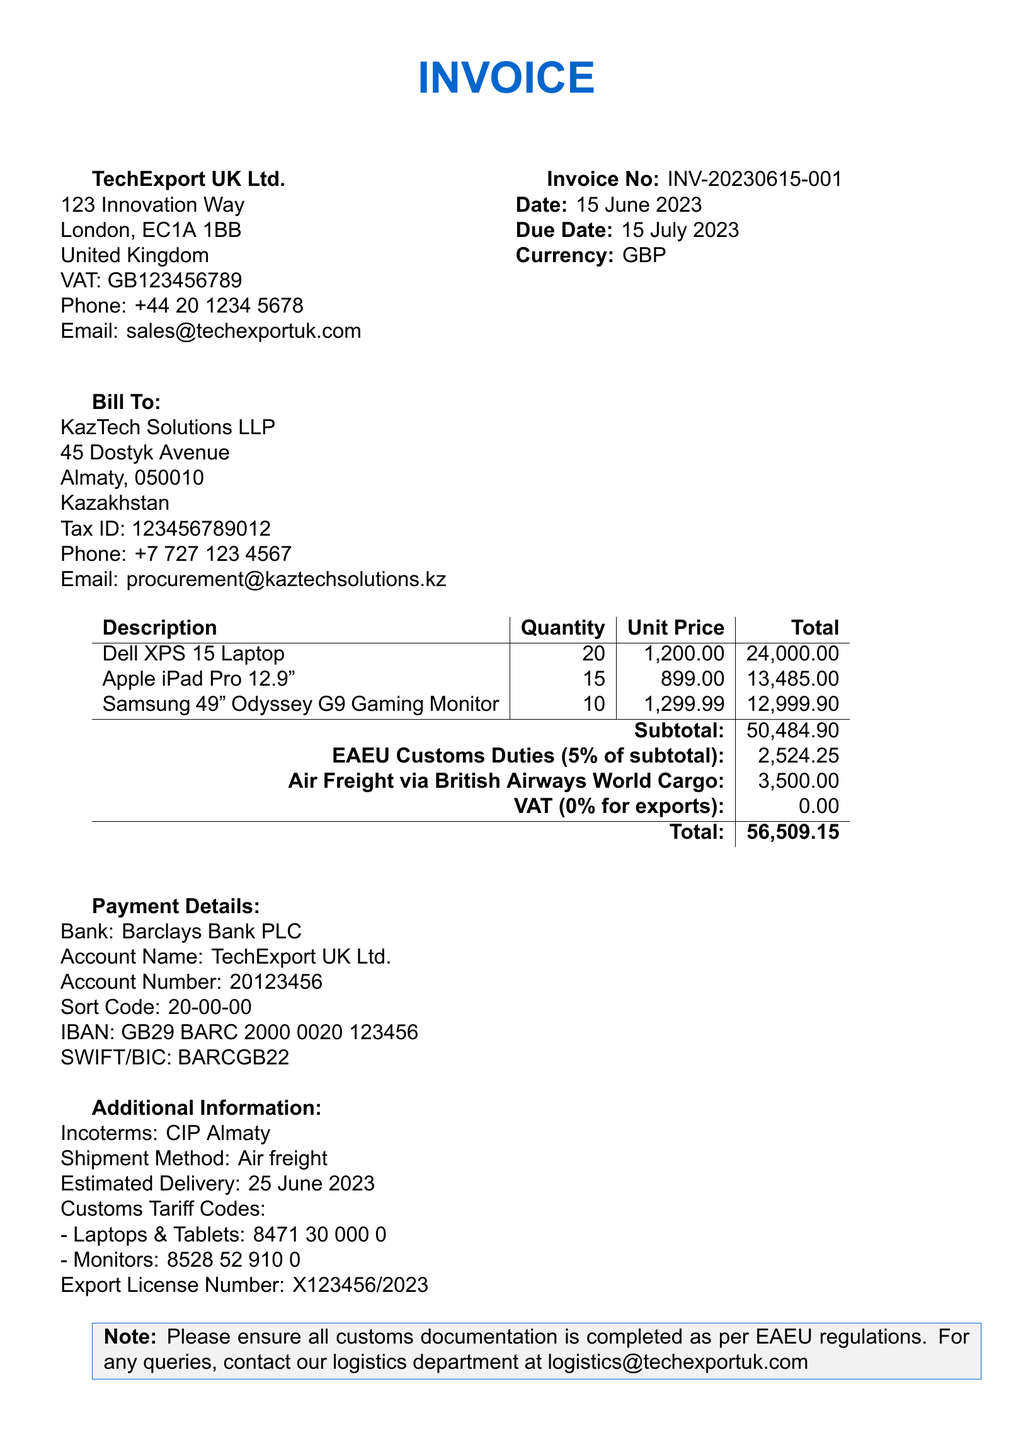what is the invoice number? The invoice number is listed as INV-20230615-001.
Answer: INV-20230615-001 what is the total amount due? The total amount due is calculated as the sum of the subtotal, customs duties, and transportation costs minus VAT.
Answer: 56509.15 who is the buyer? The buyer is the company that the invoice is addressed to, which is KazTech Solutions LLP.
Answer: KazTech Solutions LLP what is the VAT rate for this invoice? The VAT rate applied for exports in this invoice is shown as 0%.
Answer: 0% what is the transportation cost? The transportation cost is specified in the invoice as the amount charged for air freight services.
Answer: 3500.00 what is the payment due date? The payment due date is provided in the document as a specific date for when payment is required.
Answer: 15 July 2023 how many Dell XPS 15 Laptops are included in the shipment? The quantity of Dell XPS 15 Laptops is stated in the product list in the invoice.
Answer: 20 what are the customs duties for this invoice? The customs duties are specified as a percentage of the subtotal for exporting goods to EAEU countries.
Answer: 2524.25 what is the estimated delivery date? The estimated delivery date provides an expectation of when the shipment will arrive at the buyer's address.
Answer: 25 June 2023 